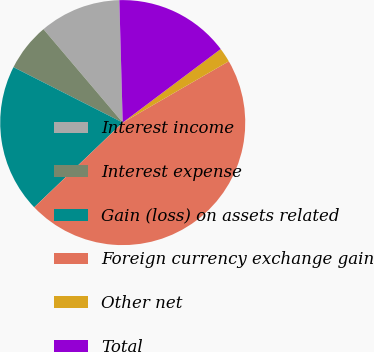<chart> <loc_0><loc_0><loc_500><loc_500><pie_chart><fcel>Interest income<fcel>Interest expense<fcel>Gain (loss) on assets related<fcel>Foreign currency exchange gain<fcel>Other net<fcel>Total<nl><fcel>10.76%<fcel>6.33%<fcel>19.62%<fcel>46.19%<fcel>1.91%<fcel>15.19%<nl></chart> 